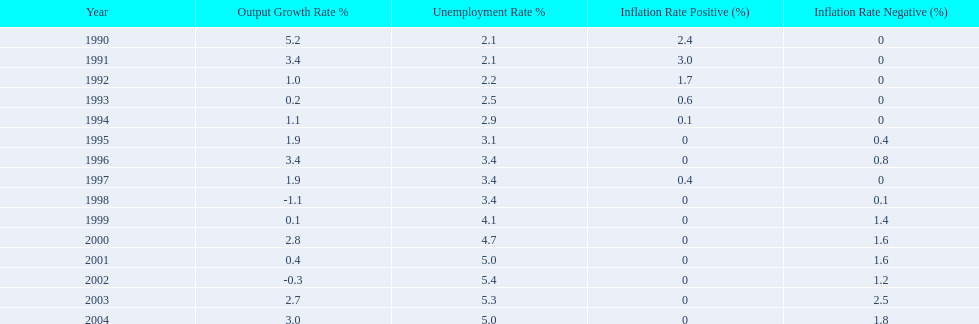In what years, between 1990 and 2004, did japan's unemployment rate reach 5% or higher? 4. 